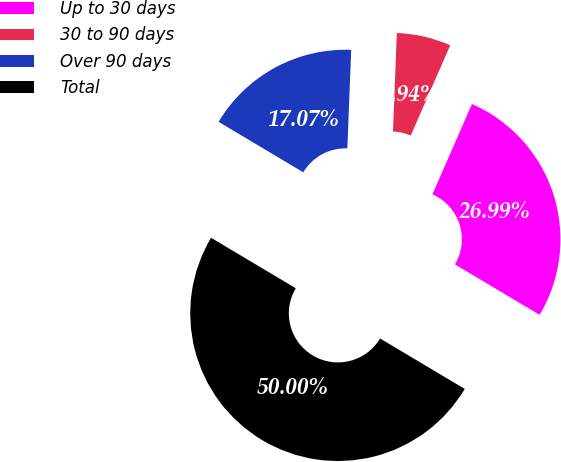Convert chart to OTSL. <chart><loc_0><loc_0><loc_500><loc_500><pie_chart><fcel>Up to 30 days<fcel>30 to 90 days<fcel>Over 90 days<fcel>Total<nl><fcel>26.99%<fcel>5.94%<fcel>17.07%<fcel>50.0%<nl></chart> 